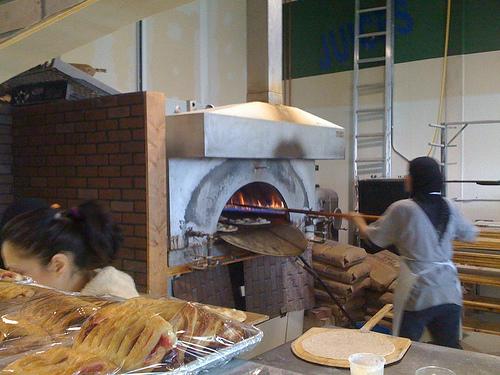What does the woman have around her waist?
Give a very brief answer. Apron. What is in the oven?
Be succinct. Pizza. Are the pastries covered with foil?
Write a very short answer. No. 